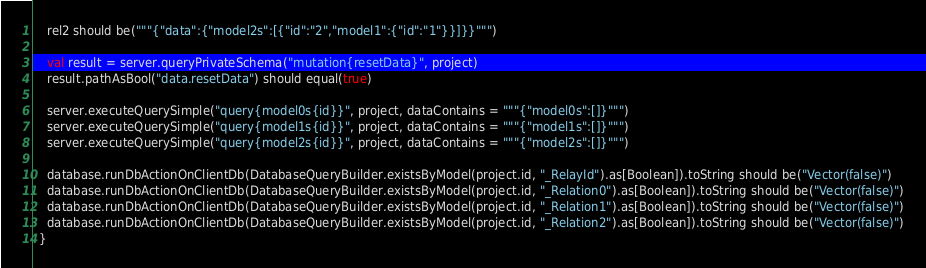<code> <loc_0><loc_0><loc_500><loc_500><_Scala_>    rel2 should be("""{"data":{"model2s":[{"id":"2","model1":{"id":"1"}}]}}""")

    val result = server.queryPrivateSchema("mutation{resetData}", project)
    result.pathAsBool("data.resetData") should equal(true)

    server.executeQuerySimple("query{model0s{id}}", project, dataContains = """{"model0s":[]}""")
    server.executeQuerySimple("query{model1s{id}}", project, dataContains = """{"model1s":[]}""")
    server.executeQuerySimple("query{model2s{id}}", project, dataContains = """{"model2s":[]}""")

    database.runDbActionOnClientDb(DatabaseQueryBuilder.existsByModel(project.id, "_RelayId").as[Boolean]).toString should be("Vector(false)")
    database.runDbActionOnClientDb(DatabaseQueryBuilder.existsByModel(project.id, "_Relation0").as[Boolean]).toString should be("Vector(false)")
    database.runDbActionOnClientDb(DatabaseQueryBuilder.existsByModel(project.id, "_Relation1").as[Boolean]).toString should be("Vector(false)")
    database.runDbActionOnClientDb(DatabaseQueryBuilder.existsByModel(project.id, "_Relation2").as[Boolean]).toString should be("Vector(false)")
  }
</code> 